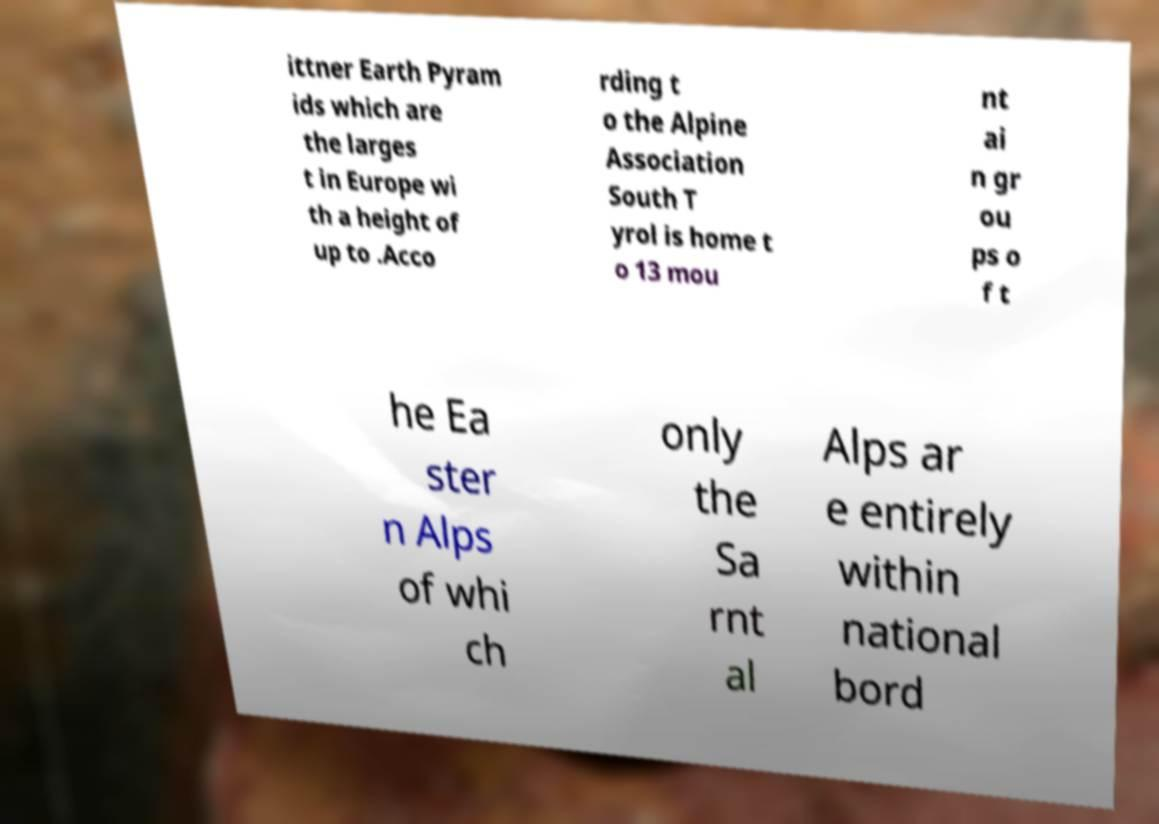Can you accurately transcribe the text from the provided image for me? ittner Earth Pyram ids which are the larges t in Europe wi th a height of up to .Acco rding t o the Alpine Association South T yrol is home t o 13 mou nt ai n gr ou ps o f t he Ea ster n Alps of whi ch only the Sa rnt al Alps ar e entirely within national bord 